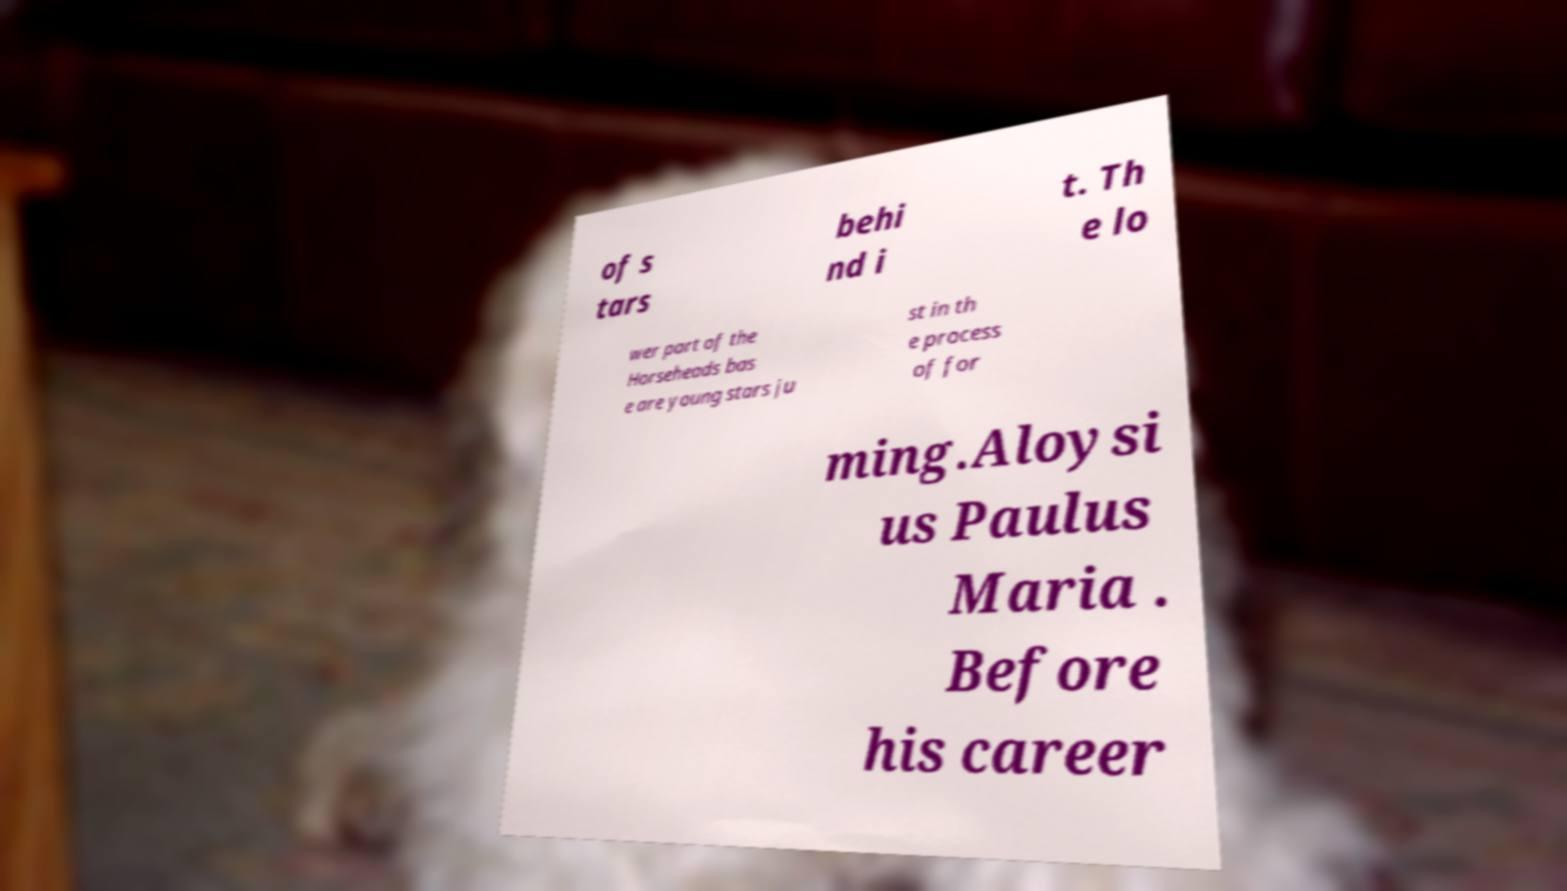Could you assist in decoding the text presented in this image and type it out clearly? of s tars behi nd i t. Th e lo wer part of the Horseheads bas e are young stars ju st in th e process of for ming.Aloysi us Paulus Maria . Before his career 